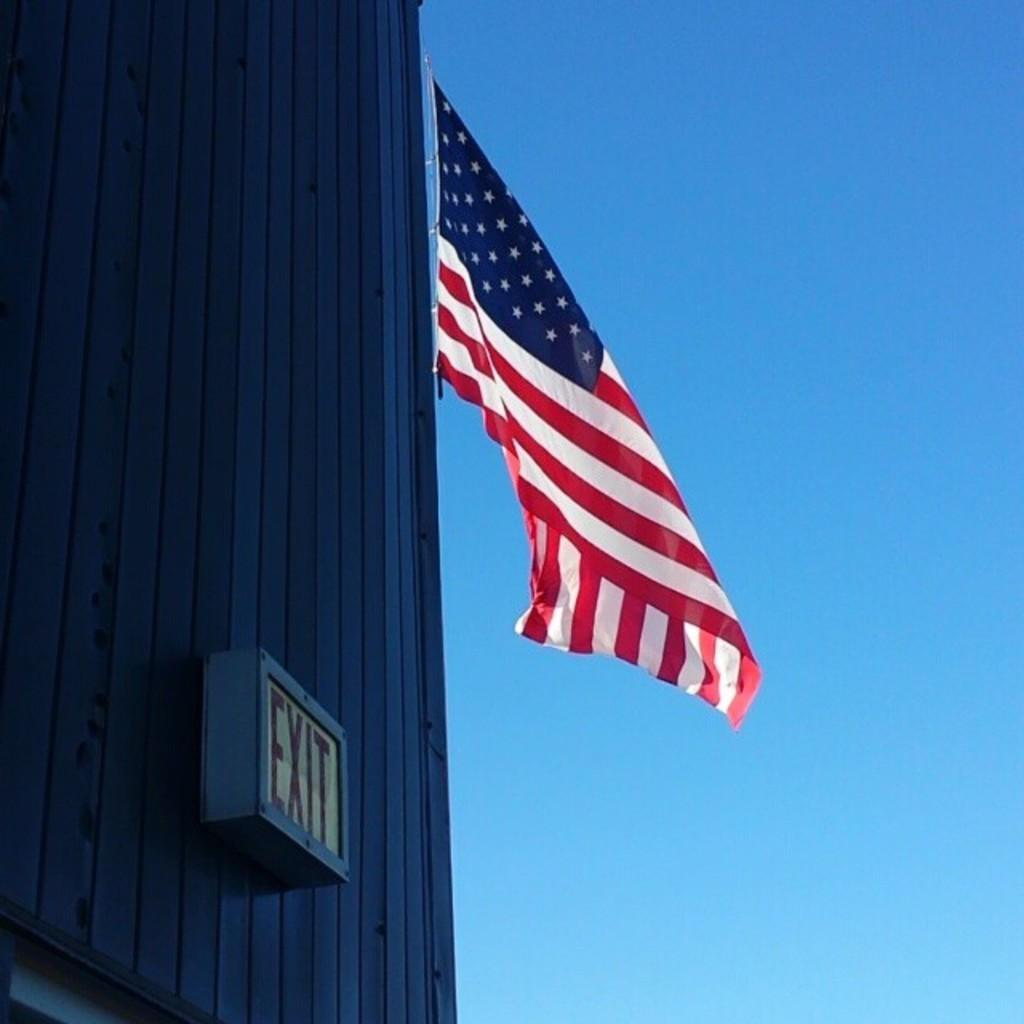What type of structure is present in the image? There is a building in the image. What is written on the board attached to the building? The board has the word "exit" on it. What additional element can be seen in the image? There is a flag in the image. What can be seen in the background of the image? The sky is visible in the image. What type of rose is being ploughed in the image? There is no rose or ploughing activity present in the image. What adjustment needs to be made to the flag in the image? There is no need for any adjustment to the flag in the image, as it appears to be stationary and properly displayed. 